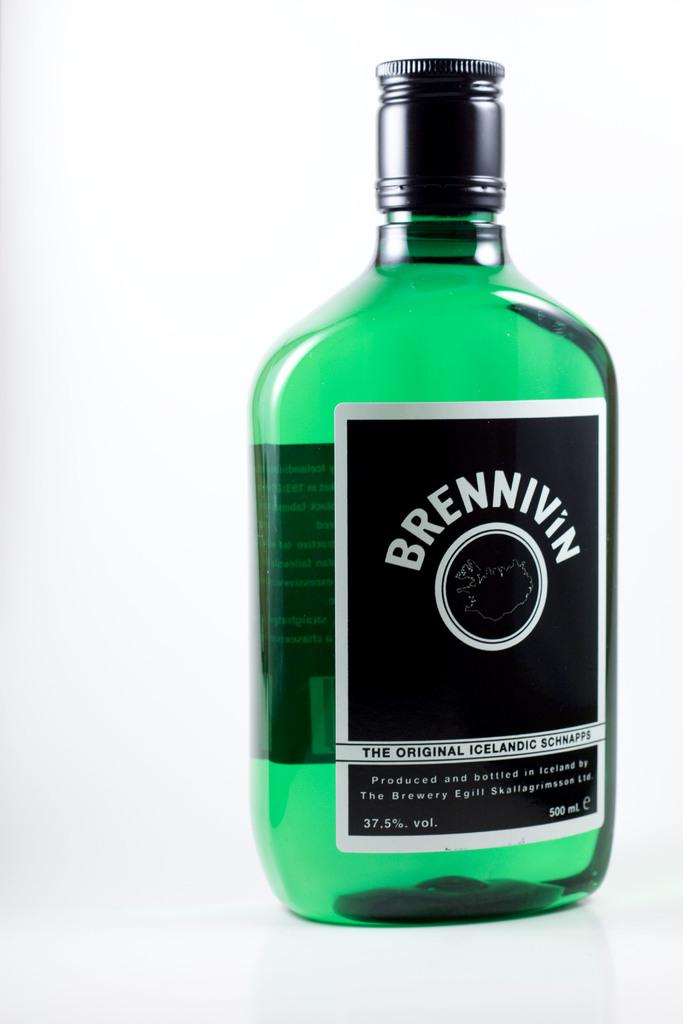<image>
Provide a brief description of the given image. bottle of green liquid with black label showing brennivin the original icelandic schnapps 